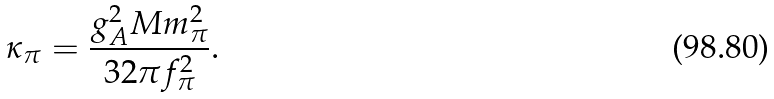<formula> <loc_0><loc_0><loc_500><loc_500>\kappa _ { \pi } = \frac { g _ { A } ^ { 2 } M m _ { \pi } ^ { 2 } } { 3 2 \pi f _ { \pi } ^ { 2 } } .</formula> 